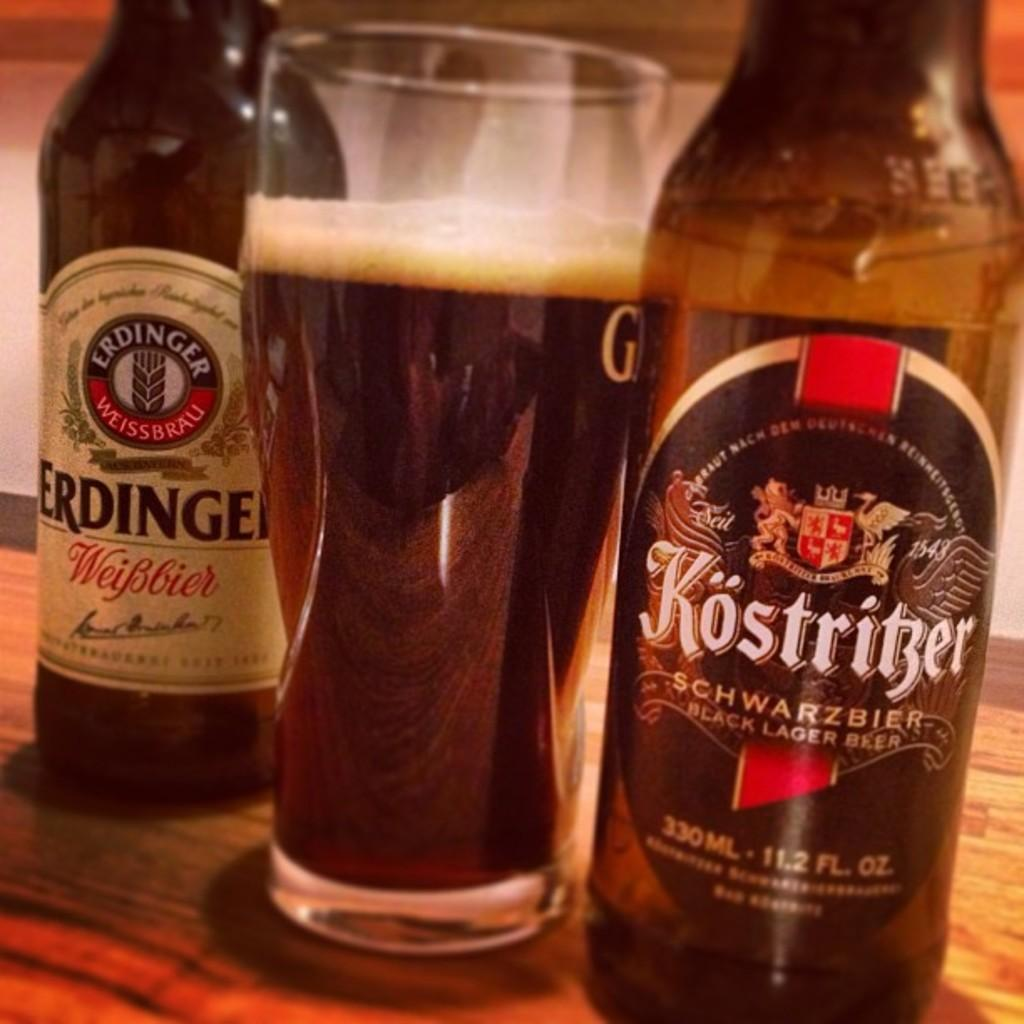<image>
Share a concise interpretation of the image provided. a bottle of kostritzer black lager next to a full glass. 